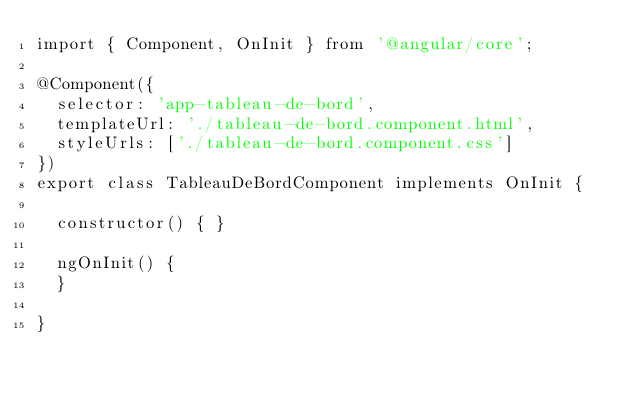Convert code to text. <code><loc_0><loc_0><loc_500><loc_500><_TypeScript_>import { Component, OnInit } from '@angular/core';

@Component({
  selector: 'app-tableau-de-bord',
  templateUrl: './tableau-de-bord.component.html',
  styleUrls: ['./tableau-de-bord.component.css']
})
export class TableauDeBordComponent implements OnInit {

  constructor() { }

  ngOnInit() {
  }

}
</code> 